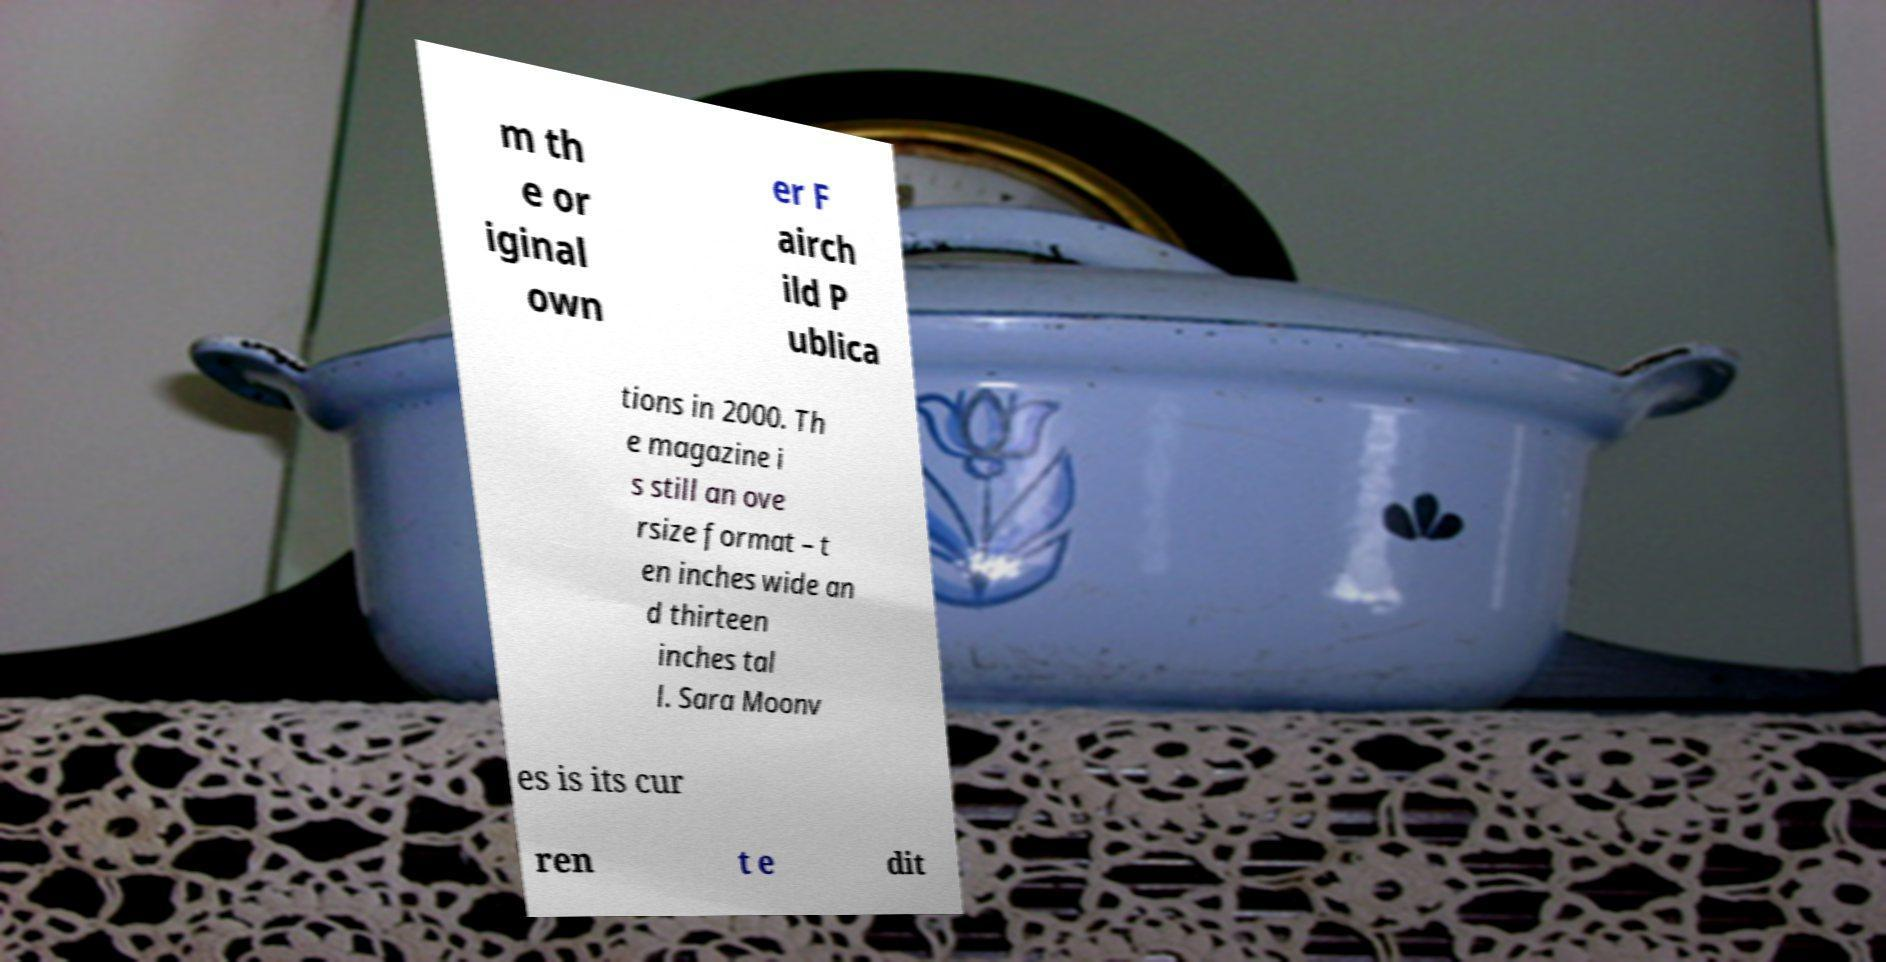Could you assist in decoding the text presented in this image and type it out clearly? m th e or iginal own er F airch ild P ublica tions in 2000. Th e magazine i s still an ove rsize format – t en inches wide an d thirteen inches tal l. Sara Moonv es is its cur ren t e dit 